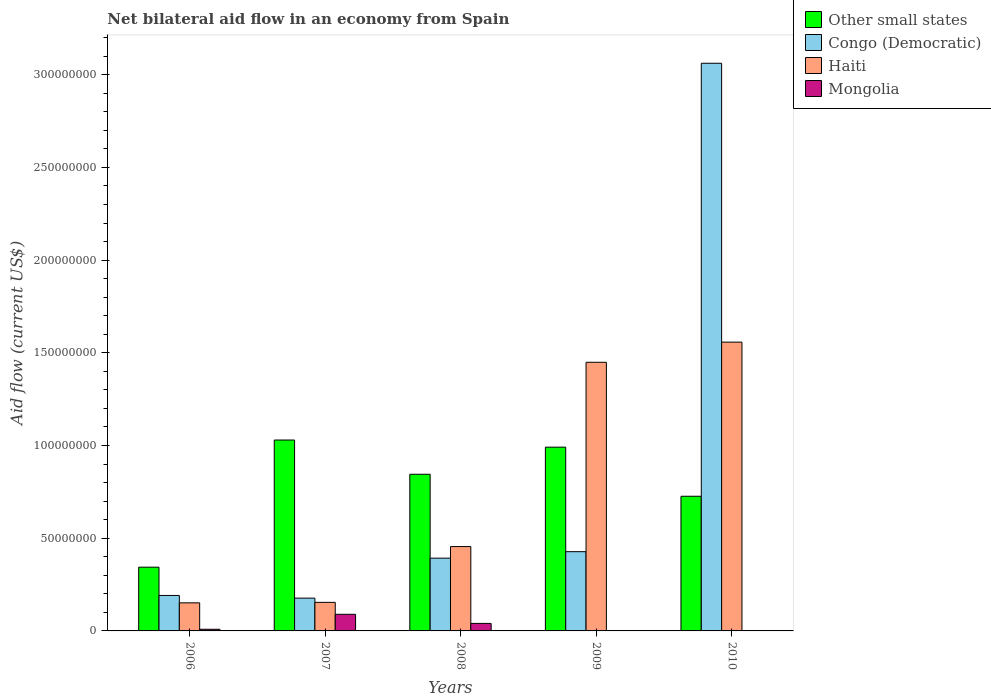Are the number of bars per tick equal to the number of legend labels?
Offer a very short reply. No. How many bars are there on the 4th tick from the left?
Your answer should be compact. 3. What is the label of the 5th group of bars from the left?
Offer a very short reply. 2010. In how many cases, is the number of bars for a given year not equal to the number of legend labels?
Your answer should be very brief. 2. What is the net bilateral aid flow in Haiti in 2007?
Your answer should be very brief. 1.54e+07. Across all years, what is the maximum net bilateral aid flow in Mongolia?
Ensure brevity in your answer.  8.96e+06. Across all years, what is the minimum net bilateral aid flow in Other small states?
Keep it short and to the point. 3.44e+07. In which year was the net bilateral aid flow in Congo (Democratic) maximum?
Offer a very short reply. 2010. What is the total net bilateral aid flow in Mongolia in the graph?
Offer a very short reply. 1.39e+07. What is the difference between the net bilateral aid flow in Congo (Democratic) in 2007 and that in 2010?
Provide a succinct answer. -2.89e+08. What is the difference between the net bilateral aid flow in Mongolia in 2007 and the net bilateral aid flow in Congo (Democratic) in 2009?
Offer a terse response. -3.38e+07. What is the average net bilateral aid flow in Congo (Democratic) per year?
Offer a very short reply. 8.50e+07. In the year 2008, what is the difference between the net bilateral aid flow in Mongolia and net bilateral aid flow in Congo (Democratic)?
Your answer should be very brief. -3.52e+07. In how many years, is the net bilateral aid flow in Mongolia greater than 20000000 US$?
Offer a very short reply. 0. What is the ratio of the net bilateral aid flow in Other small states in 2006 to that in 2008?
Offer a terse response. 0.41. Is the net bilateral aid flow in Congo (Democratic) in 2007 less than that in 2009?
Offer a very short reply. Yes. Is the difference between the net bilateral aid flow in Mongolia in 2007 and 2008 greater than the difference between the net bilateral aid flow in Congo (Democratic) in 2007 and 2008?
Provide a succinct answer. Yes. What is the difference between the highest and the second highest net bilateral aid flow in Haiti?
Your answer should be very brief. 1.09e+07. What is the difference between the highest and the lowest net bilateral aid flow in Congo (Democratic)?
Provide a short and direct response. 2.89e+08. In how many years, is the net bilateral aid flow in Other small states greater than the average net bilateral aid flow in Other small states taken over all years?
Offer a very short reply. 3. Is the sum of the net bilateral aid flow in Haiti in 2006 and 2009 greater than the maximum net bilateral aid flow in Mongolia across all years?
Your answer should be very brief. Yes. Is it the case that in every year, the sum of the net bilateral aid flow in Other small states and net bilateral aid flow in Congo (Democratic) is greater than the sum of net bilateral aid flow in Mongolia and net bilateral aid flow in Haiti?
Your answer should be very brief. No. How many bars are there?
Offer a very short reply. 18. Are all the bars in the graph horizontal?
Give a very brief answer. No. How many years are there in the graph?
Give a very brief answer. 5. What is the difference between two consecutive major ticks on the Y-axis?
Provide a succinct answer. 5.00e+07. Are the values on the major ticks of Y-axis written in scientific E-notation?
Give a very brief answer. No. Where does the legend appear in the graph?
Make the answer very short. Top right. How are the legend labels stacked?
Offer a terse response. Vertical. What is the title of the graph?
Your answer should be very brief. Net bilateral aid flow in an economy from Spain. Does "Virgin Islands" appear as one of the legend labels in the graph?
Ensure brevity in your answer.  No. What is the label or title of the Y-axis?
Keep it short and to the point. Aid flow (current US$). What is the Aid flow (current US$) of Other small states in 2006?
Provide a succinct answer. 3.44e+07. What is the Aid flow (current US$) of Congo (Democratic) in 2006?
Provide a succinct answer. 1.91e+07. What is the Aid flow (current US$) in Haiti in 2006?
Ensure brevity in your answer.  1.51e+07. What is the Aid flow (current US$) in Mongolia in 2006?
Your response must be concise. 8.90e+05. What is the Aid flow (current US$) in Other small states in 2007?
Your response must be concise. 1.03e+08. What is the Aid flow (current US$) of Congo (Democratic) in 2007?
Keep it short and to the point. 1.77e+07. What is the Aid flow (current US$) of Haiti in 2007?
Offer a terse response. 1.54e+07. What is the Aid flow (current US$) in Mongolia in 2007?
Provide a succinct answer. 8.96e+06. What is the Aid flow (current US$) in Other small states in 2008?
Make the answer very short. 8.45e+07. What is the Aid flow (current US$) in Congo (Democratic) in 2008?
Offer a terse response. 3.92e+07. What is the Aid flow (current US$) in Haiti in 2008?
Your answer should be very brief. 4.55e+07. What is the Aid flow (current US$) of Mongolia in 2008?
Your response must be concise. 4.05e+06. What is the Aid flow (current US$) of Other small states in 2009?
Provide a short and direct response. 9.91e+07. What is the Aid flow (current US$) of Congo (Democratic) in 2009?
Provide a short and direct response. 4.27e+07. What is the Aid flow (current US$) of Haiti in 2009?
Offer a terse response. 1.45e+08. What is the Aid flow (current US$) of Other small states in 2010?
Ensure brevity in your answer.  7.26e+07. What is the Aid flow (current US$) in Congo (Democratic) in 2010?
Ensure brevity in your answer.  3.06e+08. What is the Aid flow (current US$) of Haiti in 2010?
Your answer should be very brief. 1.56e+08. Across all years, what is the maximum Aid flow (current US$) in Other small states?
Provide a short and direct response. 1.03e+08. Across all years, what is the maximum Aid flow (current US$) in Congo (Democratic)?
Make the answer very short. 3.06e+08. Across all years, what is the maximum Aid flow (current US$) of Haiti?
Offer a terse response. 1.56e+08. Across all years, what is the maximum Aid flow (current US$) of Mongolia?
Offer a very short reply. 8.96e+06. Across all years, what is the minimum Aid flow (current US$) in Other small states?
Your answer should be very brief. 3.44e+07. Across all years, what is the minimum Aid flow (current US$) of Congo (Democratic)?
Offer a terse response. 1.77e+07. Across all years, what is the minimum Aid flow (current US$) in Haiti?
Offer a terse response. 1.51e+07. What is the total Aid flow (current US$) of Other small states in the graph?
Offer a terse response. 3.94e+08. What is the total Aid flow (current US$) of Congo (Democratic) in the graph?
Your response must be concise. 4.25e+08. What is the total Aid flow (current US$) of Haiti in the graph?
Ensure brevity in your answer.  3.77e+08. What is the total Aid flow (current US$) in Mongolia in the graph?
Your response must be concise. 1.39e+07. What is the difference between the Aid flow (current US$) of Other small states in 2006 and that in 2007?
Keep it short and to the point. -6.86e+07. What is the difference between the Aid flow (current US$) in Congo (Democratic) in 2006 and that in 2007?
Your answer should be compact. 1.44e+06. What is the difference between the Aid flow (current US$) in Mongolia in 2006 and that in 2007?
Keep it short and to the point. -8.07e+06. What is the difference between the Aid flow (current US$) of Other small states in 2006 and that in 2008?
Provide a short and direct response. -5.01e+07. What is the difference between the Aid flow (current US$) in Congo (Democratic) in 2006 and that in 2008?
Keep it short and to the point. -2.01e+07. What is the difference between the Aid flow (current US$) of Haiti in 2006 and that in 2008?
Ensure brevity in your answer.  -3.04e+07. What is the difference between the Aid flow (current US$) of Mongolia in 2006 and that in 2008?
Provide a short and direct response. -3.16e+06. What is the difference between the Aid flow (current US$) in Other small states in 2006 and that in 2009?
Your answer should be compact. -6.47e+07. What is the difference between the Aid flow (current US$) in Congo (Democratic) in 2006 and that in 2009?
Offer a terse response. -2.36e+07. What is the difference between the Aid flow (current US$) of Haiti in 2006 and that in 2009?
Your response must be concise. -1.30e+08. What is the difference between the Aid flow (current US$) of Other small states in 2006 and that in 2010?
Give a very brief answer. -3.83e+07. What is the difference between the Aid flow (current US$) in Congo (Democratic) in 2006 and that in 2010?
Ensure brevity in your answer.  -2.87e+08. What is the difference between the Aid flow (current US$) of Haiti in 2006 and that in 2010?
Keep it short and to the point. -1.41e+08. What is the difference between the Aid flow (current US$) in Other small states in 2007 and that in 2008?
Your answer should be very brief. 1.85e+07. What is the difference between the Aid flow (current US$) in Congo (Democratic) in 2007 and that in 2008?
Ensure brevity in your answer.  -2.16e+07. What is the difference between the Aid flow (current US$) in Haiti in 2007 and that in 2008?
Your response must be concise. -3.01e+07. What is the difference between the Aid flow (current US$) of Mongolia in 2007 and that in 2008?
Keep it short and to the point. 4.91e+06. What is the difference between the Aid flow (current US$) of Other small states in 2007 and that in 2009?
Offer a terse response. 3.85e+06. What is the difference between the Aid flow (current US$) in Congo (Democratic) in 2007 and that in 2009?
Your response must be concise. -2.50e+07. What is the difference between the Aid flow (current US$) of Haiti in 2007 and that in 2009?
Your answer should be very brief. -1.30e+08. What is the difference between the Aid flow (current US$) in Other small states in 2007 and that in 2010?
Your response must be concise. 3.03e+07. What is the difference between the Aid flow (current US$) of Congo (Democratic) in 2007 and that in 2010?
Make the answer very short. -2.89e+08. What is the difference between the Aid flow (current US$) of Haiti in 2007 and that in 2010?
Offer a terse response. -1.40e+08. What is the difference between the Aid flow (current US$) in Other small states in 2008 and that in 2009?
Provide a short and direct response. -1.46e+07. What is the difference between the Aid flow (current US$) of Congo (Democratic) in 2008 and that in 2009?
Ensure brevity in your answer.  -3.49e+06. What is the difference between the Aid flow (current US$) in Haiti in 2008 and that in 2009?
Provide a short and direct response. -9.94e+07. What is the difference between the Aid flow (current US$) in Other small states in 2008 and that in 2010?
Offer a very short reply. 1.19e+07. What is the difference between the Aid flow (current US$) in Congo (Democratic) in 2008 and that in 2010?
Ensure brevity in your answer.  -2.67e+08. What is the difference between the Aid flow (current US$) in Haiti in 2008 and that in 2010?
Your answer should be compact. -1.10e+08. What is the difference between the Aid flow (current US$) in Other small states in 2009 and that in 2010?
Make the answer very short. 2.65e+07. What is the difference between the Aid flow (current US$) in Congo (Democratic) in 2009 and that in 2010?
Your response must be concise. -2.63e+08. What is the difference between the Aid flow (current US$) of Haiti in 2009 and that in 2010?
Provide a succinct answer. -1.09e+07. What is the difference between the Aid flow (current US$) of Other small states in 2006 and the Aid flow (current US$) of Congo (Democratic) in 2007?
Ensure brevity in your answer.  1.67e+07. What is the difference between the Aid flow (current US$) of Other small states in 2006 and the Aid flow (current US$) of Haiti in 2007?
Offer a terse response. 1.90e+07. What is the difference between the Aid flow (current US$) in Other small states in 2006 and the Aid flow (current US$) in Mongolia in 2007?
Offer a very short reply. 2.54e+07. What is the difference between the Aid flow (current US$) of Congo (Democratic) in 2006 and the Aid flow (current US$) of Haiti in 2007?
Your response must be concise. 3.73e+06. What is the difference between the Aid flow (current US$) in Congo (Democratic) in 2006 and the Aid flow (current US$) in Mongolia in 2007?
Ensure brevity in your answer.  1.02e+07. What is the difference between the Aid flow (current US$) of Haiti in 2006 and the Aid flow (current US$) of Mongolia in 2007?
Give a very brief answer. 6.18e+06. What is the difference between the Aid flow (current US$) of Other small states in 2006 and the Aid flow (current US$) of Congo (Democratic) in 2008?
Give a very brief answer. -4.87e+06. What is the difference between the Aid flow (current US$) of Other small states in 2006 and the Aid flow (current US$) of Haiti in 2008?
Offer a terse response. -1.11e+07. What is the difference between the Aid flow (current US$) in Other small states in 2006 and the Aid flow (current US$) in Mongolia in 2008?
Your answer should be compact. 3.03e+07. What is the difference between the Aid flow (current US$) in Congo (Democratic) in 2006 and the Aid flow (current US$) in Haiti in 2008?
Your response must be concise. -2.64e+07. What is the difference between the Aid flow (current US$) of Congo (Democratic) in 2006 and the Aid flow (current US$) of Mongolia in 2008?
Your answer should be compact. 1.51e+07. What is the difference between the Aid flow (current US$) in Haiti in 2006 and the Aid flow (current US$) in Mongolia in 2008?
Offer a very short reply. 1.11e+07. What is the difference between the Aid flow (current US$) of Other small states in 2006 and the Aid flow (current US$) of Congo (Democratic) in 2009?
Make the answer very short. -8.36e+06. What is the difference between the Aid flow (current US$) of Other small states in 2006 and the Aid flow (current US$) of Haiti in 2009?
Make the answer very short. -1.11e+08. What is the difference between the Aid flow (current US$) of Congo (Democratic) in 2006 and the Aid flow (current US$) of Haiti in 2009?
Offer a very short reply. -1.26e+08. What is the difference between the Aid flow (current US$) of Other small states in 2006 and the Aid flow (current US$) of Congo (Democratic) in 2010?
Your answer should be compact. -2.72e+08. What is the difference between the Aid flow (current US$) of Other small states in 2006 and the Aid flow (current US$) of Haiti in 2010?
Provide a short and direct response. -1.21e+08. What is the difference between the Aid flow (current US$) of Congo (Democratic) in 2006 and the Aid flow (current US$) of Haiti in 2010?
Give a very brief answer. -1.37e+08. What is the difference between the Aid flow (current US$) in Other small states in 2007 and the Aid flow (current US$) in Congo (Democratic) in 2008?
Provide a short and direct response. 6.37e+07. What is the difference between the Aid flow (current US$) of Other small states in 2007 and the Aid flow (current US$) of Haiti in 2008?
Provide a short and direct response. 5.75e+07. What is the difference between the Aid flow (current US$) of Other small states in 2007 and the Aid flow (current US$) of Mongolia in 2008?
Keep it short and to the point. 9.89e+07. What is the difference between the Aid flow (current US$) of Congo (Democratic) in 2007 and the Aid flow (current US$) of Haiti in 2008?
Keep it short and to the point. -2.78e+07. What is the difference between the Aid flow (current US$) of Congo (Democratic) in 2007 and the Aid flow (current US$) of Mongolia in 2008?
Ensure brevity in your answer.  1.36e+07. What is the difference between the Aid flow (current US$) in Haiti in 2007 and the Aid flow (current US$) in Mongolia in 2008?
Ensure brevity in your answer.  1.14e+07. What is the difference between the Aid flow (current US$) in Other small states in 2007 and the Aid flow (current US$) in Congo (Democratic) in 2009?
Ensure brevity in your answer.  6.02e+07. What is the difference between the Aid flow (current US$) in Other small states in 2007 and the Aid flow (current US$) in Haiti in 2009?
Offer a terse response. -4.19e+07. What is the difference between the Aid flow (current US$) in Congo (Democratic) in 2007 and the Aid flow (current US$) in Haiti in 2009?
Your answer should be compact. -1.27e+08. What is the difference between the Aid flow (current US$) of Other small states in 2007 and the Aid flow (current US$) of Congo (Democratic) in 2010?
Your response must be concise. -2.03e+08. What is the difference between the Aid flow (current US$) of Other small states in 2007 and the Aid flow (current US$) of Haiti in 2010?
Offer a very short reply. -5.28e+07. What is the difference between the Aid flow (current US$) in Congo (Democratic) in 2007 and the Aid flow (current US$) in Haiti in 2010?
Offer a terse response. -1.38e+08. What is the difference between the Aid flow (current US$) in Other small states in 2008 and the Aid flow (current US$) in Congo (Democratic) in 2009?
Make the answer very short. 4.18e+07. What is the difference between the Aid flow (current US$) of Other small states in 2008 and the Aid flow (current US$) of Haiti in 2009?
Offer a terse response. -6.04e+07. What is the difference between the Aid flow (current US$) in Congo (Democratic) in 2008 and the Aid flow (current US$) in Haiti in 2009?
Provide a short and direct response. -1.06e+08. What is the difference between the Aid flow (current US$) in Other small states in 2008 and the Aid flow (current US$) in Congo (Democratic) in 2010?
Make the answer very short. -2.22e+08. What is the difference between the Aid flow (current US$) in Other small states in 2008 and the Aid flow (current US$) in Haiti in 2010?
Keep it short and to the point. -7.13e+07. What is the difference between the Aid flow (current US$) in Congo (Democratic) in 2008 and the Aid flow (current US$) in Haiti in 2010?
Offer a terse response. -1.17e+08. What is the difference between the Aid flow (current US$) in Other small states in 2009 and the Aid flow (current US$) in Congo (Democratic) in 2010?
Your answer should be very brief. -2.07e+08. What is the difference between the Aid flow (current US$) of Other small states in 2009 and the Aid flow (current US$) of Haiti in 2010?
Your answer should be compact. -5.66e+07. What is the difference between the Aid flow (current US$) of Congo (Democratic) in 2009 and the Aid flow (current US$) of Haiti in 2010?
Offer a very short reply. -1.13e+08. What is the average Aid flow (current US$) of Other small states per year?
Offer a very short reply. 7.87e+07. What is the average Aid flow (current US$) of Congo (Democratic) per year?
Give a very brief answer. 8.50e+07. What is the average Aid flow (current US$) in Haiti per year?
Make the answer very short. 7.53e+07. What is the average Aid flow (current US$) in Mongolia per year?
Offer a terse response. 2.78e+06. In the year 2006, what is the difference between the Aid flow (current US$) of Other small states and Aid flow (current US$) of Congo (Democratic)?
Offer a very short reply. 1.52e+07. In the year 2006, what is the difference between the Aid flow (current US$) in Other small states and Aid flow (current US$) in Haiti?
Your response must be concise. 1.92e+07. In the year 2006, what is the difference between the Aid flow (current US$) in Other small states and Aid flow (current US$) in Mongolia?
Offer a terse response. 3.35e+07. In the year 2006, what is the difference between the Aid flow (current US$) in Congo (Democratic) and Aid flow (current US$) in Haiti?
Your response must be concise. 3.99e+06. In the year 2006, what is the difference between the Aid flow (current US$) in Congo (Democratic) and Aid flow (current US$) in Mongolia?
Make the answer very short. 1.82e+07. In the year 2006, what is the difference between the Aid flow (current US$) of Haiti and Aid flow (current US$) of Mongolia?
Provide a short and direct response. 1.42e+07. In the year 2007, what is the difference between the Aid flow (current US$) in Other small states and Aid flow (current US$) in Congo (Democratic)?
Ensure brevity in your answer.  8.53e+07. In the year 2007, what is the difference between the Aid flow (current US$) of Other small states and Aid flow (current US$) of Haiti?
Provide a succinct answer. 8.76e+07. In the year 2007, what is the difference between the Aid flow (current US$) of Other small states and Aid flow (current US$) of Mongolia?
Make the answer very short. 9.40e+07. In the year 2007, what is the difference between the Aid flow (current US$) in Congo (Democratic) and Aid flow (current US$) in Haiti?
Provide a short and direct response. 2.29e+06. In the year 2007, what is the difference between the Aid flow (current US$) in Congo (Democratic) and Aid flow (current US$) in Mongolia?
Provide a short and direct response. 8.73e+06. In the year 2007, what is the difference between the Aid flow (current US$) in Haiti and Aid flow (current US$) in Mongolia?
Offer a very short reply. 6.44e+06. In the year 2008, what is the difference between the Aid flow (current US$) in Other small states and Aid flow (current US$) in Congo (Democratic)?
Your response must be concise. 4.52e+07. In the year 2008, what is the difference between the Aid flow (current US$) in Other small states and Aid flow (current US$) in Haiti?
Keep it short and to the point. 3.90e+07. In the year 2008, what is the difference between the Aid flow (current US$) in Other small states and Aid flow (current US$) in Mongolia?
Your response must be concise. 8.04e+07. In the year 2008, what is the difference between the Aid flow (current US$) in Congo (Democratic) and Aid flow (current US$) in Haiti?
Keep it short and to the point. -6.25e+06. In the year 2008, what is the difference between the Aid flow (current US$) in Congo (Democratic) and Aid flow (current US$) in Mongolia?
Provide a succinct answer. 3.52e+07. In the year 2008, what is the difference between the Aid flow (current US$) in Haiti and Aid flow (current US$) in Mongolia?
Your answer should be compact. 4.14e+07. In the year 2009, what is the difference between the Aid flow (current US$) of Other small states and Aid flow (current US$) of Congo (Democratic)?
Keep it short and to the point. 5.64e+07. In the year 2009, what is the difference between the Aid flow (current US$) of Other small states and Aid flow (current US$) of Haiti?
Make the answer very short. -4.58e+07. In the year 2009, what is the difference between the Aid flow (current US$) of Congo (Democratic) and Aid flow (current US$) of Haiti?
Your answer should be very brief. -1.02e+08. In the year 2010, what is the difference between the Aid flow (current US$) in Other small states and Aid flow (current US$) in Congo (Democratic)?
Give a very brief answer. -2.34e+08. In the year 2010, what is the difference between the Aid flow (current US$) in Other small states and Aid flow (current US$) in Haiti?
Offer a very short reply. -8.31e+07. In the year 2010, what is the difference between the Aid flow (current US$) in Congo (Democratic) and Aid flow (current US$) in Haiti?
Give a very brief answer. 1.50e+08. What is the ratio of the Aid flow (current US$) in Other small states in 2006 to that in 2007?
Give a very brief answer. 0.33. What is the ratio of the Aid flow (current US$) in Congo (Democratic) in 2006 to that in 2007?
Make the answer very short. 1.08. What is the ratio of the Aid flow (current US$) of Haiti in 2006 to that in 2007?
Your answer should be compact. 0.98. What is the ratio of the Aid flow (current US$) in Mongolia in 2006 to that in 2007?
Your answer should be compact. 0.1. What is the ratio of the Aid flow (current US$) of Other small states in 2006 to that in 2008?
Offer a terse response. 0.41. What is the ratio of the Aid flow (current US$) in Congo (Democratic) in 2006 to that in 2008?
Keep it short and to the point. 0.49. What is the ratio of the Aid flow (current US$) of Haiti in 2006 to that in 2008?
Your answer should be very brief. 0.33. What is the ratio of the Aid flow (current US$) of Mongolia in 2006 to that in 2008?
Make the answer very short. 0.22. What is the ratio of the Aid flow (current US$) in Other small states in 2006 to that in 2009?
Your response must be concise. 0.35. What is the ratio of the Aid flow (current US$) in Congo (Democratic) in 2006 to that in 2009?
Make the answer very short. 0.45. What is the ratio of the Aid flow (current US$) in Haiti in 2006 to that in 2009?
Offer a very short reply. 0.1. What is the ratio of the Aid flow (current US$) of Other small states in 2006 to that in 2010?
Keep it short and to the point. 0.47. What is the ratio of the Aid flow (current US$) of Congo (Democratic) in 2006 to that in 2010?
Your answer should be compact. 0.06. What is the ratio of the Aid flow (current US$) in Haiti in 2006 to that in 2010?
Your answer should be compact. 0.1. What is the ratio of the Aid flow (current US$) in Other small states in 2007 to that in 2008?
Provide a short and direct response. 1.22. What is the ratio of the Aid flow (current US$) in Congo (Democratic) in 2007 to that in 2008?
Make the answer very short. 0.45. What is the ratio of the Aid flow (current US$) of Haiti in 2007 to that in 2008?
Provide a short and direct response. 0.34. What is the ratio of the Aid flow (current US$) in Mongolia in 2007 to that in 2008?
Provide a short and direct response. 2.21. What is the ratio of the Aid flow (current US$) of Other small states in 2007 to that in 2009?
Your answer should be very brief. 1.04. What is the ratio of the Aid flow (current US$) in Congo (Democratic) in 2007 to that in 2009?
Provide a succinct answer. 0.41. What is the ratio of the Aid flow (current US$) in Haiti in 2007 to that in 2009?
Make the answer very short. 0.11. What is the ratio of the Aid flow (current US$) of Other small states in 2007 to that in 2010?
Keep it short and to the point. 1.42. What is the ratio of the Aid flow (current US$) in Congo (Democratic) in 2007 to that in 2010?
Your response must be concise. 0.06. What is the ratio of the Aid flow (current US$) in Haiti in 2007 to that in 2010?
Keep it short and to the point. 0.1. What is the ratio of the Aid flow (current US$) in Other small states in 2008 to that in 2009?
Provide a succinct answer. 0.85. What is the ratio of the Aid flow (current US$) of Congo (Democratic) in 2008 to that in 2009?
Offer a very short reply. 0.92. What is the ratio of the Aid flow (current US$) of Haiti in 2008 to that in 2009?
Keep it short and to the point. 0.31. What is the ratio of the Aid flow (current US$) of Other small states in 2008 to that in 2010?
Keep it short and to the point. 1.16. What is the ratio of the Aid flow (current US$) in Congo (Democratic) in 2008 to that in 2010?
Provide a succinct answer. 0.13. What is the ratio of the Aid flow (current US$) of Haiti in 2008 to that in 2010?
Make the answer very short. 0.29. What is the ratio of the Aid flow (current US$) in Other small states in 2009 to that in 2010?
Provide a short and direct response. 1.36. What is the ratio of the Aid flow (current US$) in Congo (Democratic) in 2009 to that in 2010?
Provide a short and direct response. 0.14. What is the ratio of the Aid flow (current US$) of Haiti in 2009 to that in 2010?
Your answer should be very brief. 0.93. What is the difference between the highest and the second highest Aid flow (current US$) in Other small states?
Make the answer very short. 3.85e+06. What is the difference between the highest and the second highest Aid flow (current US$) of Congo (Democratic)?
Give a very brief answer. 2.63e+08. What is the difference between the highest and the second highest Aid flow (current US$) of Haiti?
Your answer should be very brief. 1.09e+07. What is the difference between the highest and the second highest Aid flow (current US$) of Mongolia?
Provide a short and direct response. 4.91e+06. What is the difference between the highest and the lowest Aid flow (current US$) of Other small states?
Make the answer very short. 6.86e+07. What is the difference between the highest and the lowest Aid flow (current US$) in Congo (Democratic)?
Your answer should be very brief. 2.89e+08. What is the difference between the highest and the lowest Aid flow (current US$) in Haiti?
Provide a short and direct response. 1.41e+08. What is the difference between the highest and the lowest Aid flow (current US$) of Mongolia?
Offer a terse response. 8.96e+06. 